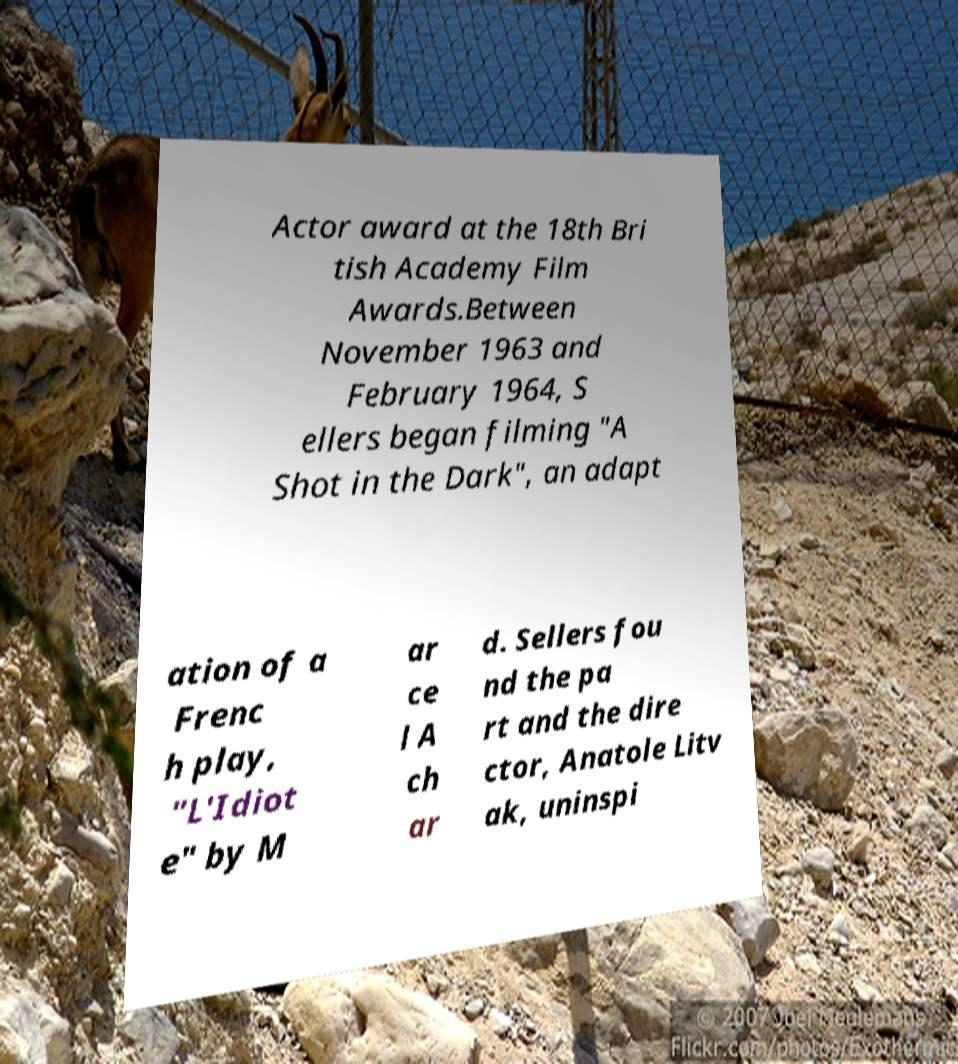Please read and relay the text visible in this image. What does it say? Actor award at the 18th Bri tish Academy Film Awards.Between November 1963 and February 1964, S ellers began filming "A Shot in the Dark", an adapt ation of a Frenc h play, "L'Idiot e" by M ar ce l A ch ar d. Sellers fou nd the pa rt and the dire ctor, Anatole Litv ak, uninspi 